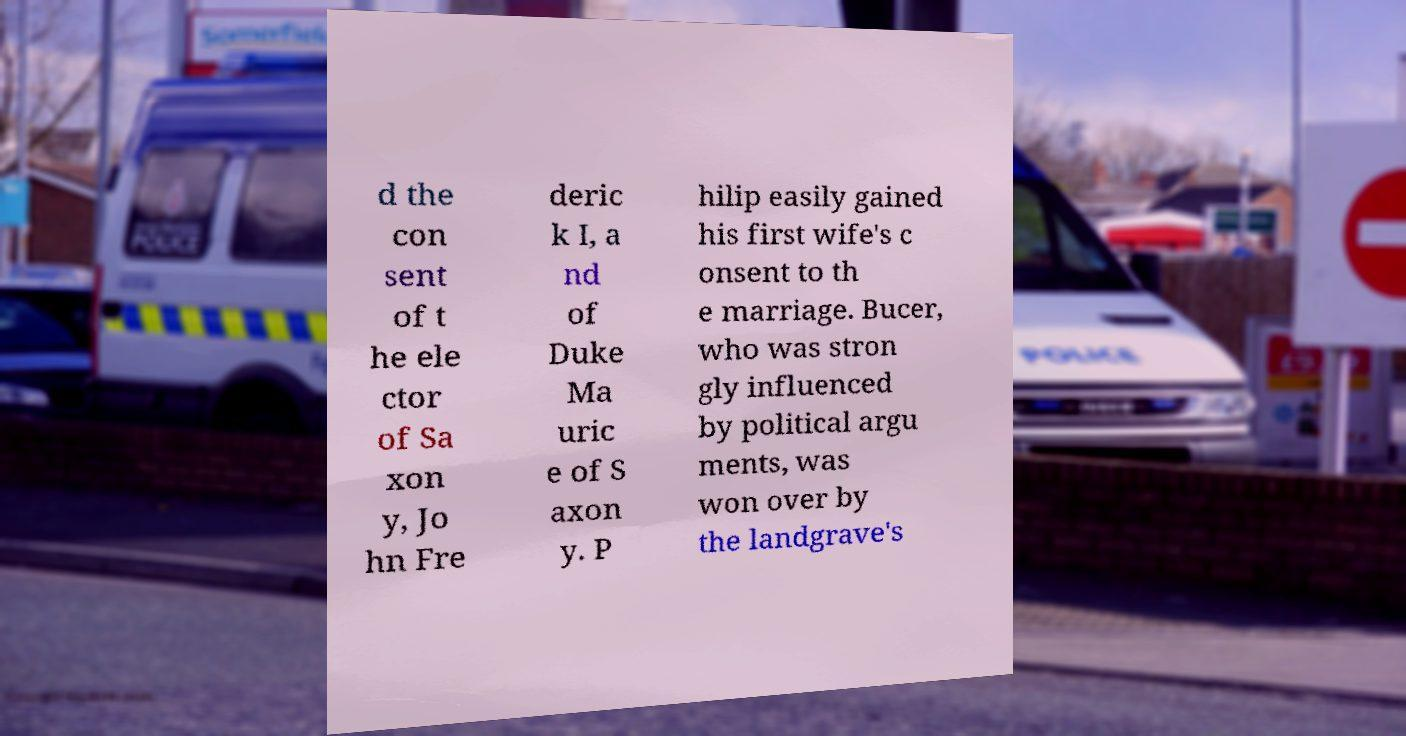Please read and relay the text visible in this image. What does it say? d the con sent of t he ele ctor of Sa xon y, Jo hn Fre deric k I, a nd of Duke Ma uric e of S axon y. P hilip easily gained his first wife's c onsent to th e marriage. Bucer, who was stron gly influenced by political argu ments, was won over by the landgrave's 